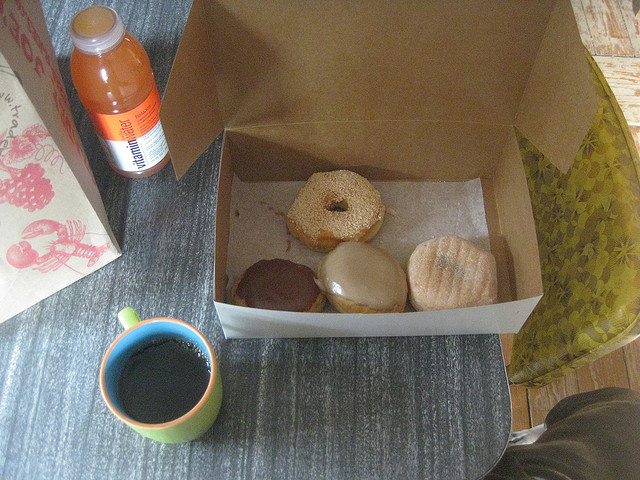<image>What type of water is on the left? I am not sure about the type of water is on the left. But it might be vitamin water. What type of water is on the left? I don't know what type of water is on the left. It could be vitamin water, coffee, or none. 